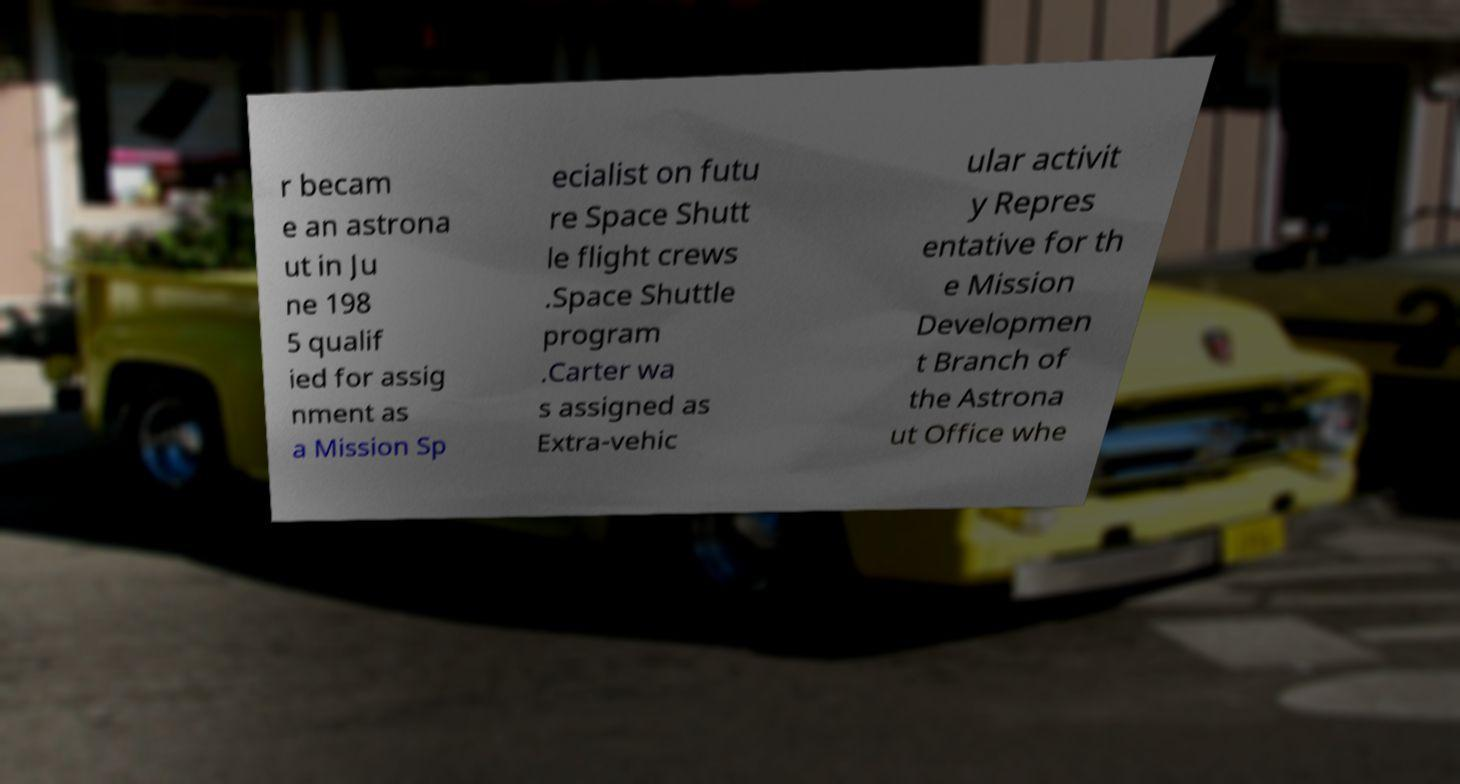Could you assist in decoding the text presented in this image and type it out clearly? r becam e an astrona ut in Ju ne 198 5 qualif ied for assig nment as a Mission Sp ecialist on futu re Space Shutt le flight crews .Space Shuttle program .Carter wa s assigned as Extra-vehic ular activit y Repres entative for th e Mission Developmen t Branch of the Astrona ut Office whe 